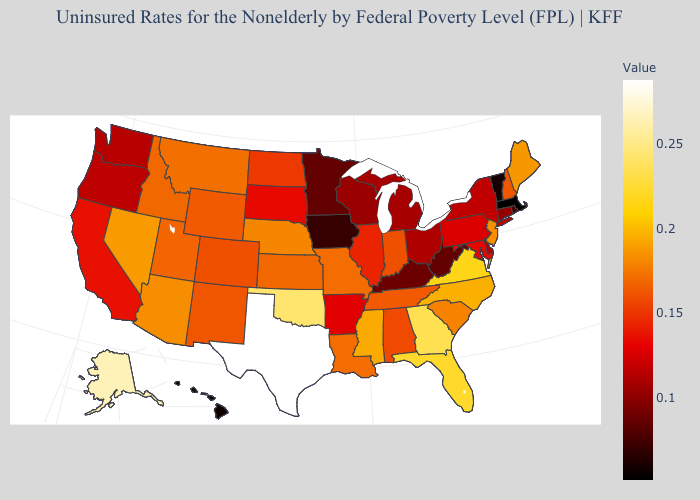Which states hav the highest value in the West?
Write a very short answer. Alaska. Does Texas have a lower value than Wisconsin?
Give a very brief answer. No. Among the states that border Utah , does Idaho have the highest value?
Quick response, please. No. Which states have the lowest value in the South?
Short answer required. West Virginia. Among the states that border Alabama , does Tennessee have the lowest value?
Keep it brief. Yes. Does Michigan have a higher value than Massachusetts?
Short answer required. Yes. Among the states that border Kentucky , which have the highest value?
Be succinct. Virginia. 